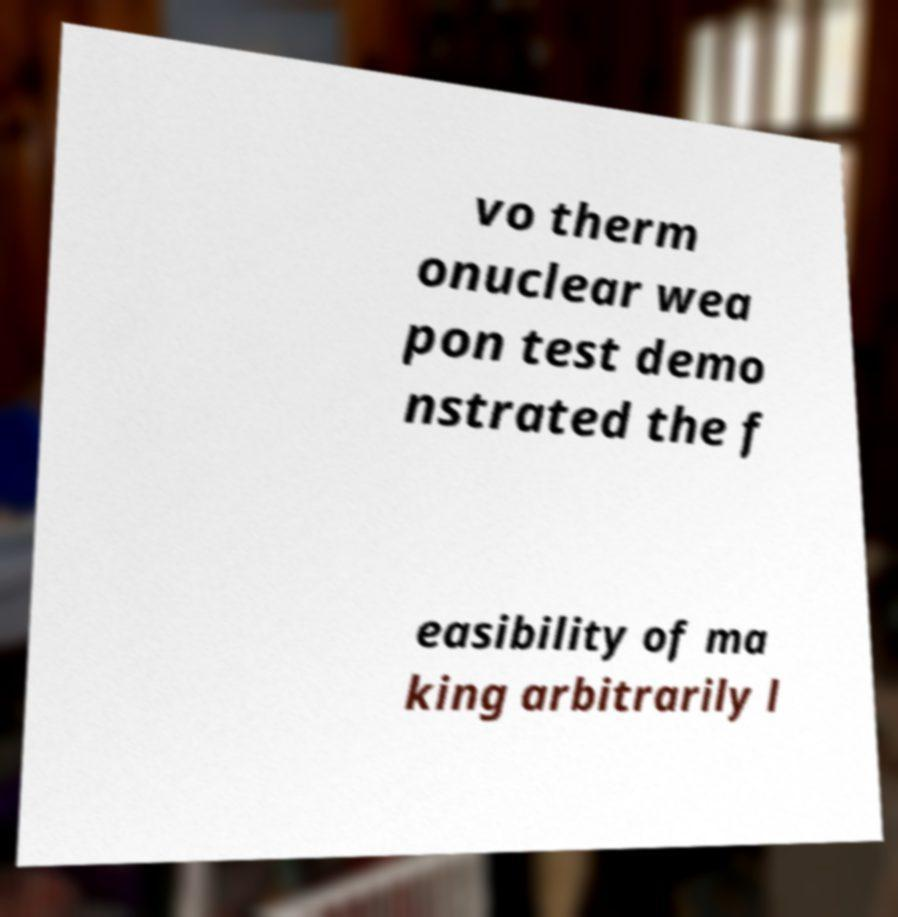Please identify and transcribe the text found in this image. vo therm onuclear wea pon test demo nstrated the f easibility of ma king arbitrarily l 